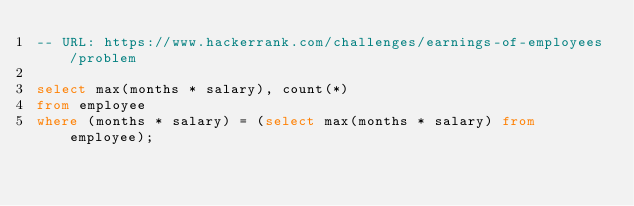<code> <loc_0><loc_0><loc_500><loc_500><_SQL_>-- URL: https://www.hackerrank.com/challenges/earnings-of-employees/problem

select max(months * salary), count(*)
from employee
where (months * salary) = (select max(months * salary) from employee);
</code> 